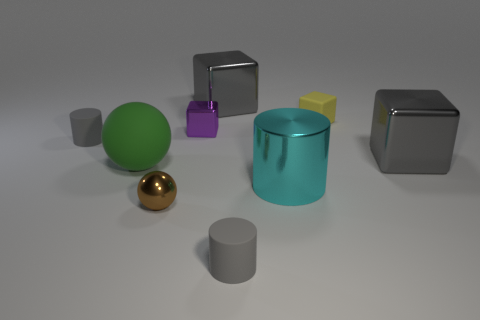Subtract all cyan cylinders. How many cylinders are left? 2 Subtract 2 spheres. How many spheres are left? 0 Subtract all cyan cylinders. How many cylinders are left? 2 Subtract all cylinders. How many objects are left? 6 Subtract all green cylinders. How many brown spheres are left? 1 Add 5 yellow matte things. How many yellow matte things exist? 6 Subtract 0 yellow cylinders. How many objects are left? 9 Subtract all cyan blocks. Subtract all green balls. How many blocks are left? 4 Subtract all large matte balls. Subtract all cubes. How many objects are left? 4 Add 3 large green objects. How many large green objects are left? 4 